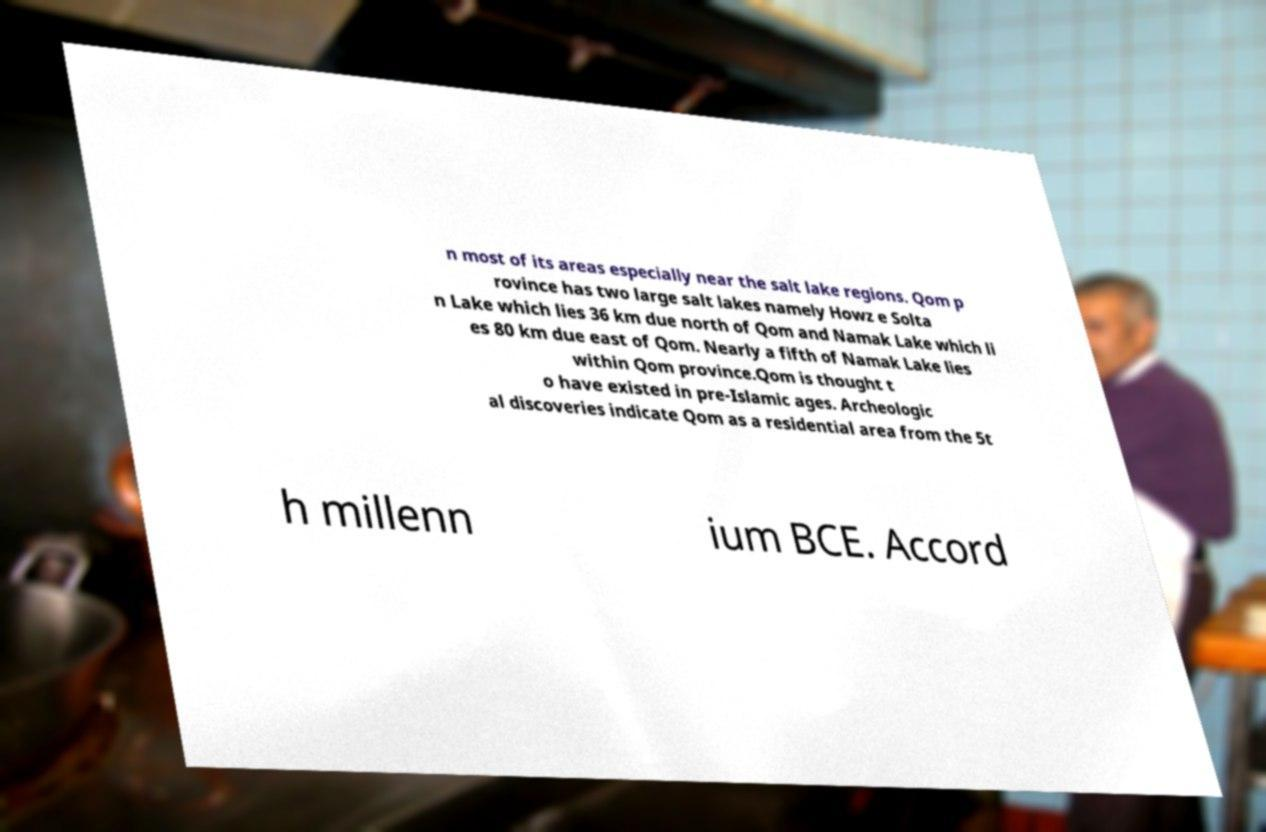I need the written content from this picture converted into text. Can you do that? n most of its areas especially near the salt lake regions. Qom p rovince has two large salt lakes namely Howz e Solta n Lake which lies 36 km due north of Qom and Namak Lake which li es 80 km due east of Qom. Nearly a fifth of Namak Lake lies within Qom province.Qom is thought t o have existed in pre-Islamic ages. Archeologic al discoveries indicate Qom as a residential area from the 5t h millenn ium BCE. Accord 